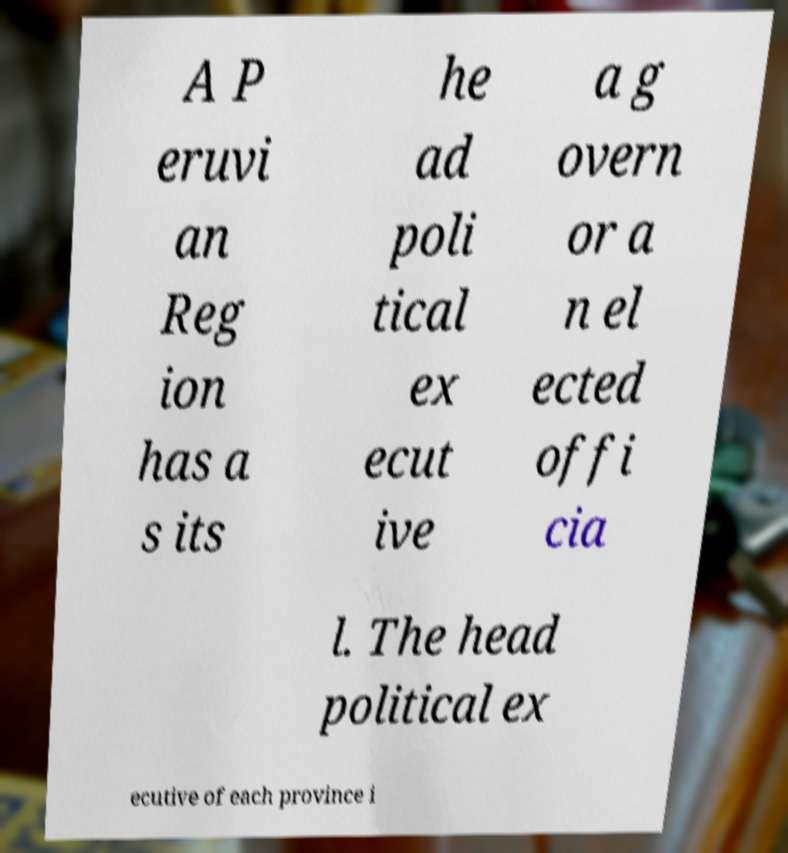Can you read and provide the text displayed in the image?This photo seems to have some interesting text. Can you extract and type it out for me? A P eruvi an Reg ion has a s its he ad poli tical ex ecut ive a g overn or a n el ected offi cia l. The head political ex ecutive of each province i 